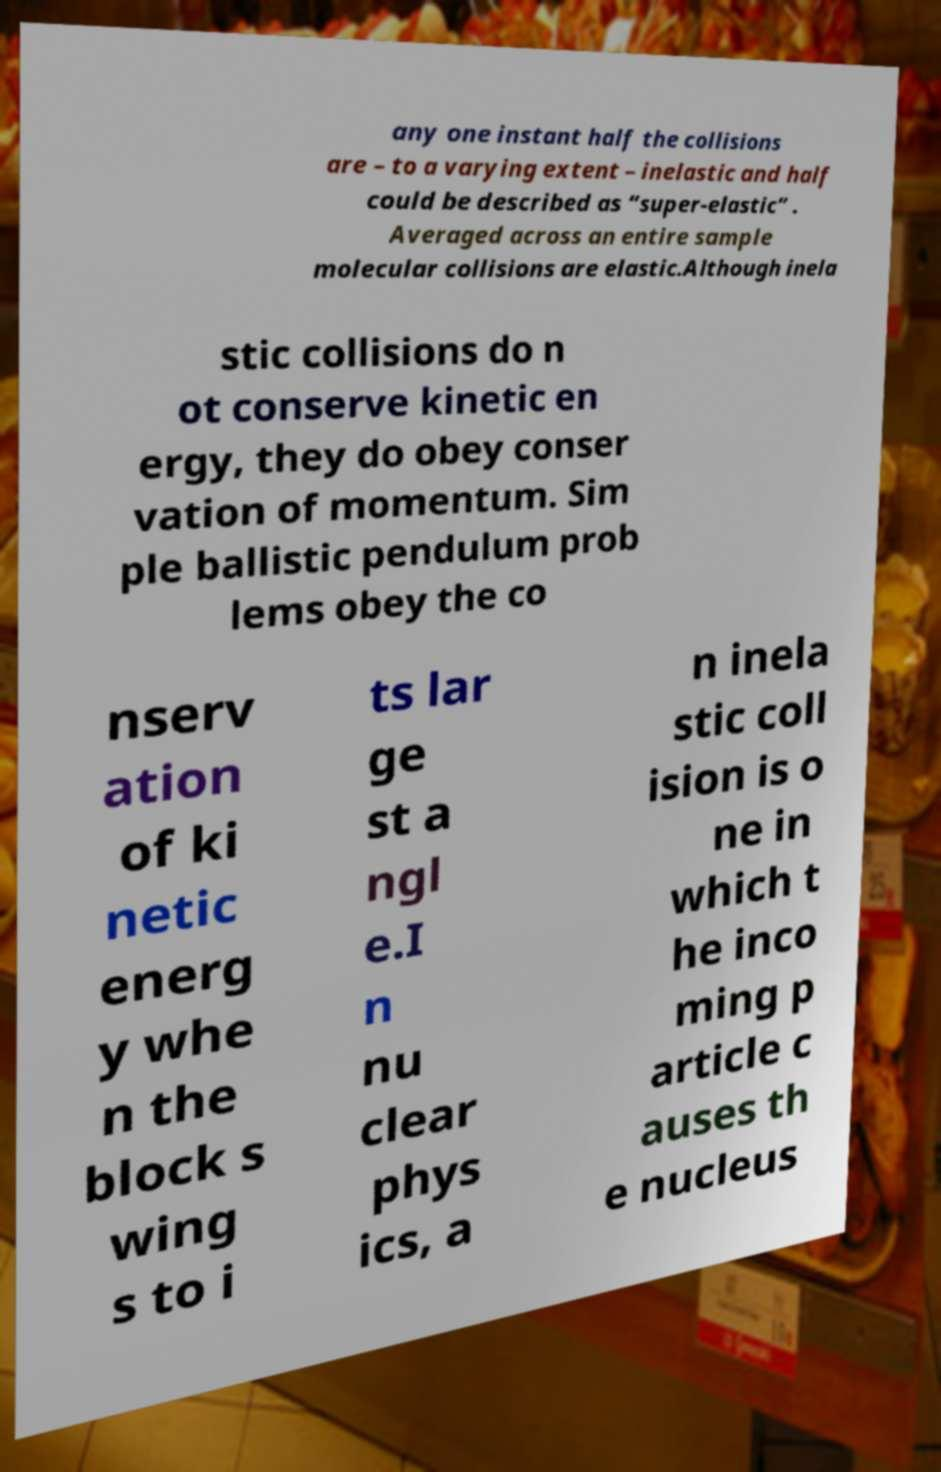Please read and relay the text visible in this image. What does it say? any one instant half the collisions are – to a varying extent – inelastic and half could be described as “super-elastic” . Averaged across an entire sample molecular collisions are elastic.Although inela stic collisions do n ot conserve kinetic en ergy, they do obey conser vation of momentum. Sim ple ballistic pendulum prob lems obey the co nserv ation of ki netic energ y whe n the block s wing s to i ts lar ge st a ngl e.I n nu clear phys ics, a n inela stic coll ision is o ne in which t he inco ming p article c auses th e nucleus 